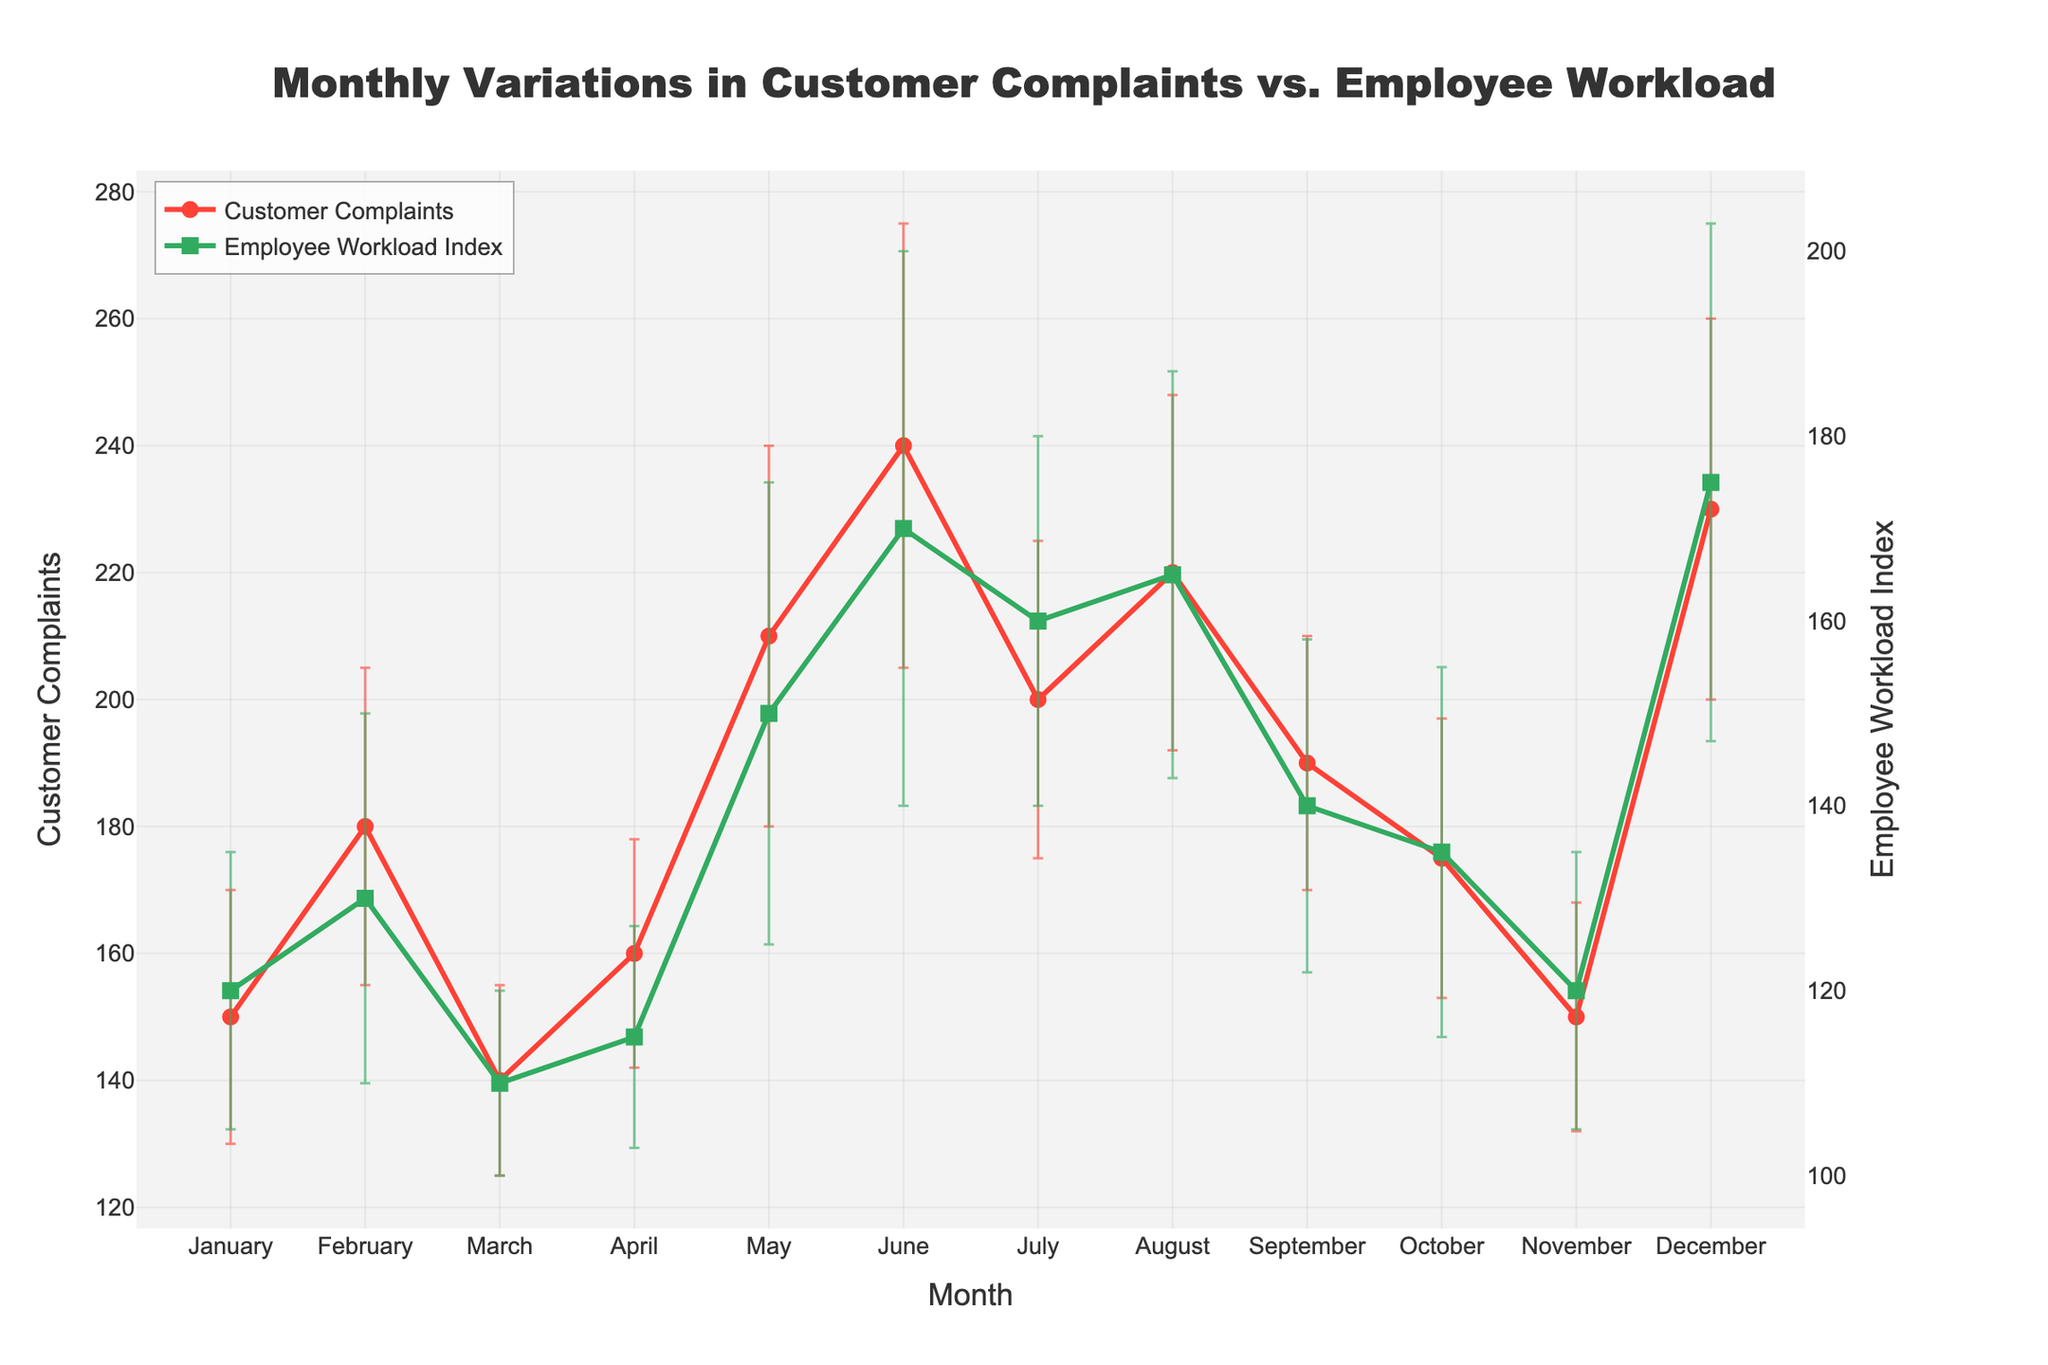What's the title of the plot? The title of the plot is usually found at the top center of the figure in large font size, which provides a summary of what the plot represents. In this case, the title is "Monthly Variations in Customer Complaints vs. Employee Workload."
Answer: Monthly Variations in Customer Complaints vs. Employee Workload What color represents the Customer Complaints line? The color of the Customer Complaints line is indicated by both the line and the markers on the plot. By looking at the legend and the lines, we can see that the Customer Complaints line is represented by a red color.
Answer: Red How does the Employee Workload Index change from January to June? To see the change, we look at the plot points and the error bars for the Employee Workload Index from January to June in the green line. January starts at 120 and June goes up to 170, showing a consistent increase over these months.
Answer: It increases Which month has the highest number of Customer Complaints? By looking at the peaks of the red line and identifying the highest point on the graph, we can see that the red line reaches its highest value in June, indicating the highest number of complaints.
Answer: June What is the range of Employee Workload Index in November? The range can be calculated using the data point for November, which is 120, and considering its error bars. With the error margin of 15, the Employee Workload Index in November ranges from 105 to 135.
Answer: 105 to 135 Compare the Customer Complaints between February and October. Which month had more complaints? By comparing the y-values of the red line for February and October, we can see that February's point is higher (180 complaints) compared to October's (175 complaints).
Answer: February On average, is the Employee Workload Index higher in the first six months (January to June) or the last six months (July to December)? To find the average, we sum the Employee Workload Index values in both periods and divide by the number of months (6). First six months: (120+130+110+115+150+170)/6 = 132.5; Last six months: (160+165+140+135+120+175)/6 = 149.2. Thus, the average is higher in the last six months.
Answer: Last six months Why might there be error bars on the plot? Error bars indicate the variability or uncertainty in the data points. By showing error bars, the plot provides a visual representation of the possible range the actual values could fall within, based on the calculated error margins.
Answer: To show variability/uncertainty Is there a month where both Customer Complaints and Employee Workload Index values are at their peak? By cross-referencing the peaks of both lines, we note that June has the highest points for both Customer Complaints (240) and Employee Workload Index (170).
Answer: June How does the pattern of Customer Complaints relate to the Employee Workload Index throughout the months? By examining the overall trend of both lines, one might notice that as the Employee Workload Index increases, particularly from May to August, there is also an increase in Customer Complaints, suggesting a possible correlation.
Answer: They seem to correlate 